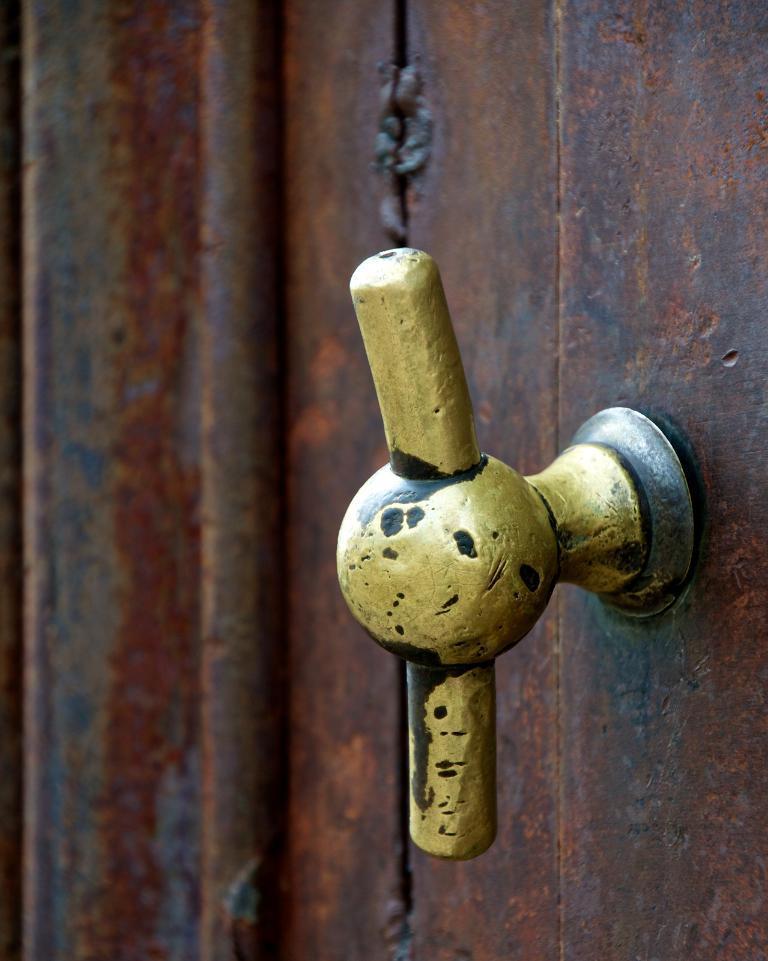How would you summarize this image in a sentence or two? In this picture we can see a metal object, door handle and a pipe. 